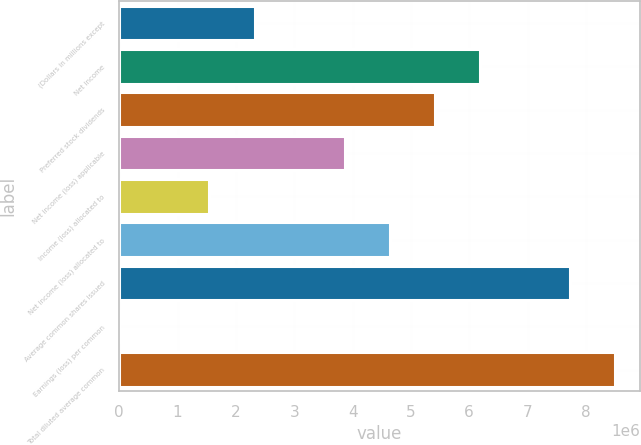<chart> <loc_0><loc_0><loc_500><loc_500><bar_chart><fcel>(Dollars in millions except<fcel>Net income<fcel>Preferred stock dividends<fcel>Net income (loss) applicable<fcel>Income (loss) allocated to<fcel>Net income (loss) allocated to<fcel>Average common shares issued<fcel>Earnings (loss) per common<fcel>Total diluted average common<nl><fcel>2.31857e+06<fcel>6.18286e+06<fcel>5.41e+06<fcel>3.86429e+06<fcel>1.54571e+06<fcel>4.63714e+06<fcel>7.72857e+06<fcel>0.29<fcel>8.50143e+06<nl></chart> 